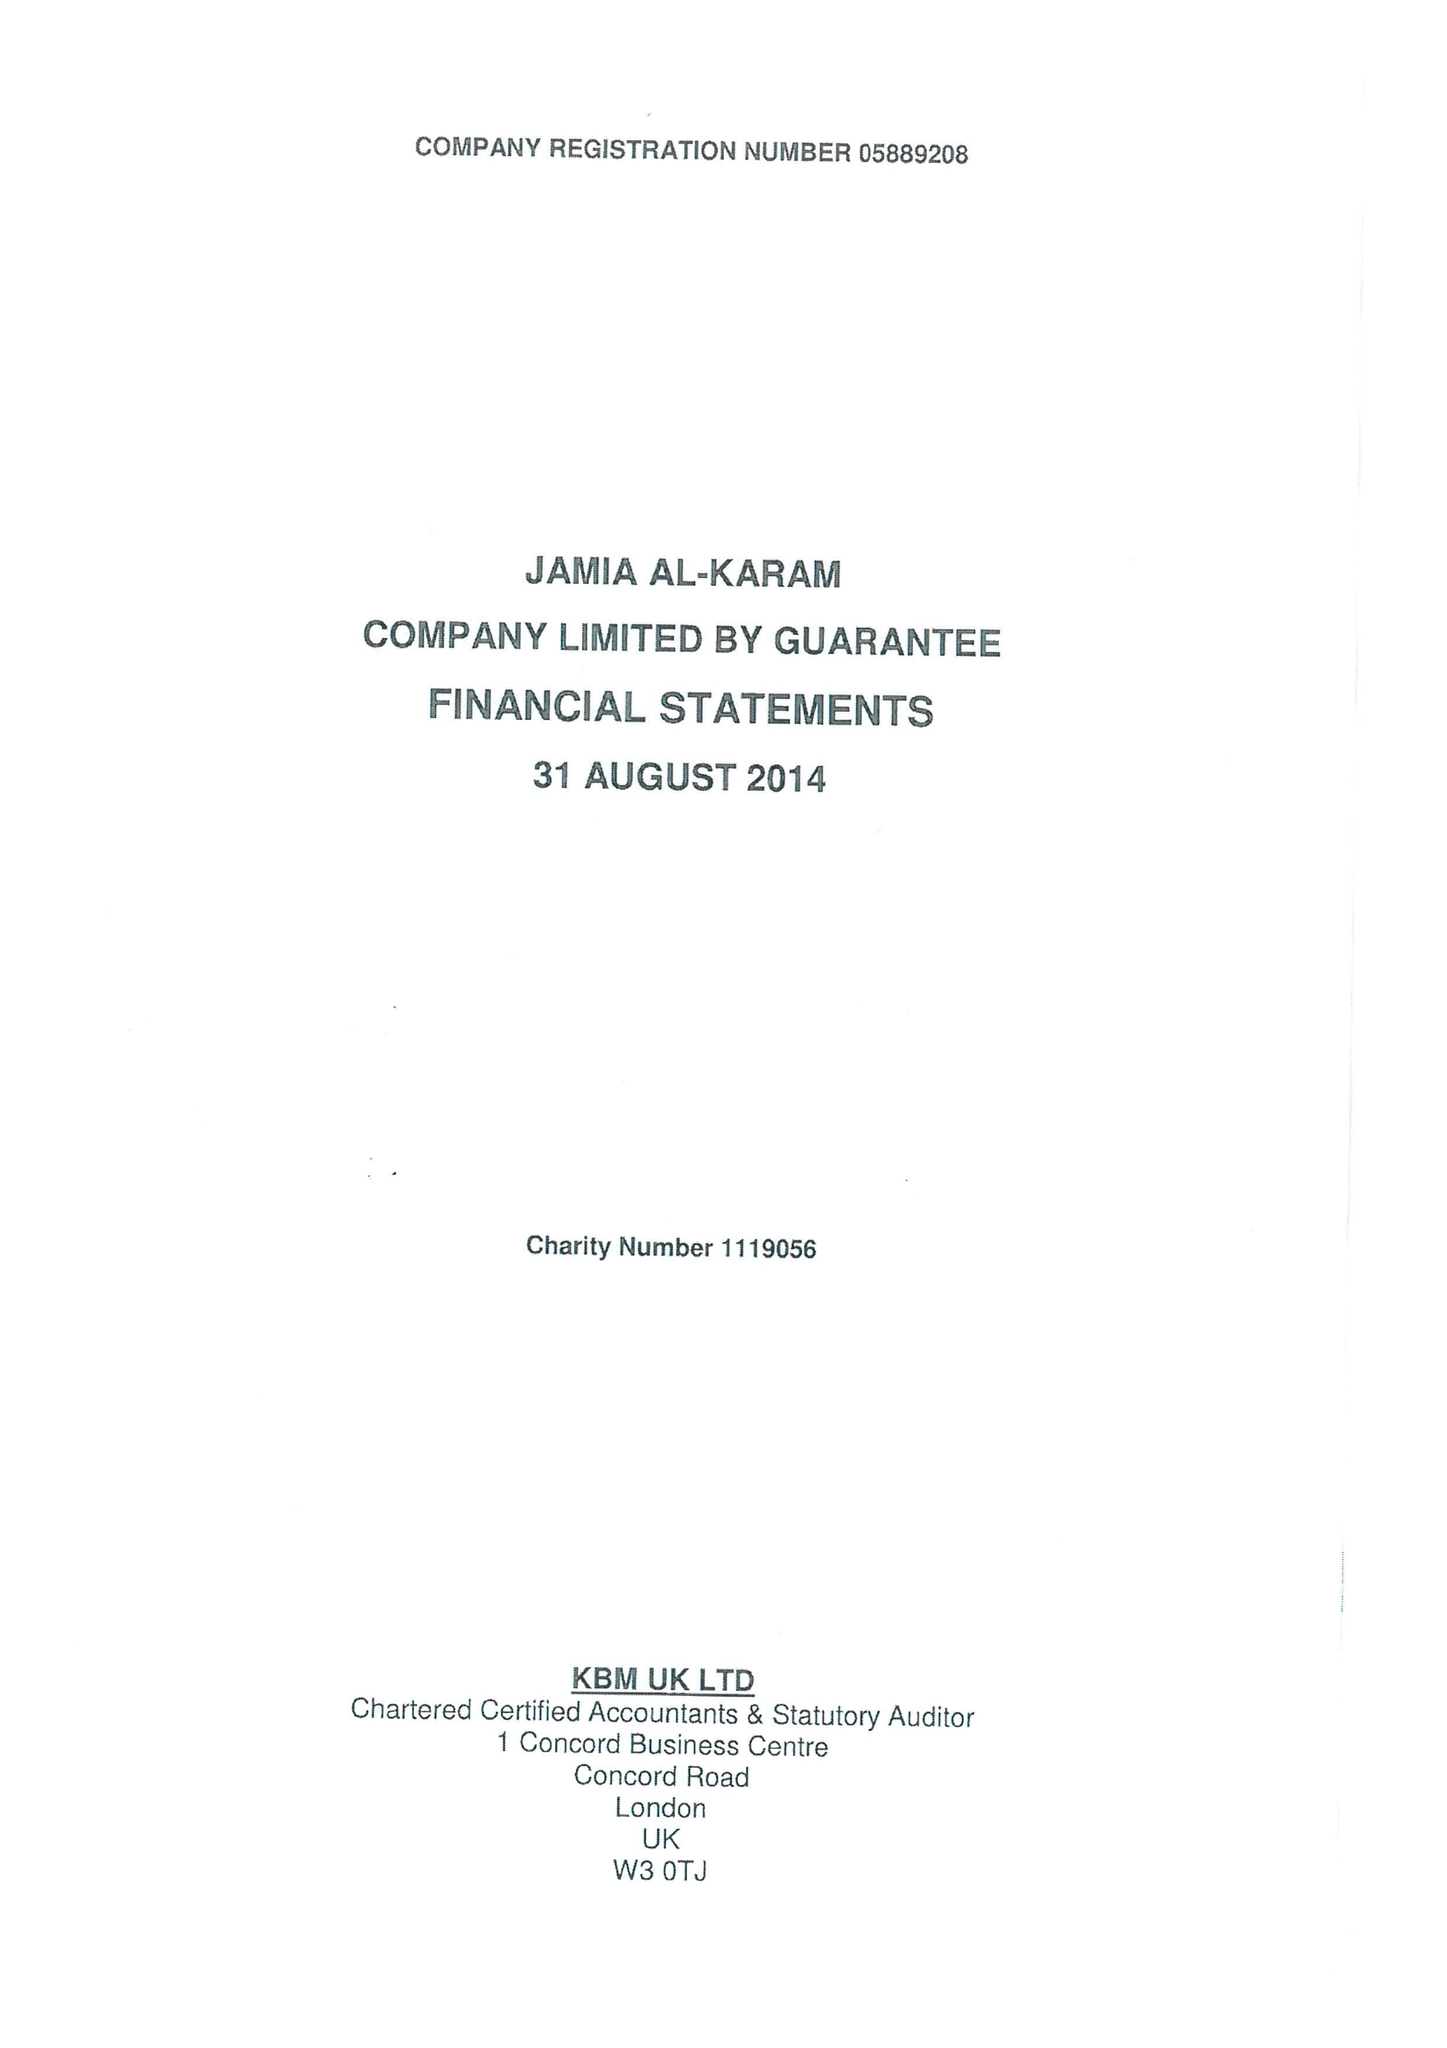What is the value for the charity_number?
Answer the question using a single word or phrase. 1119056 